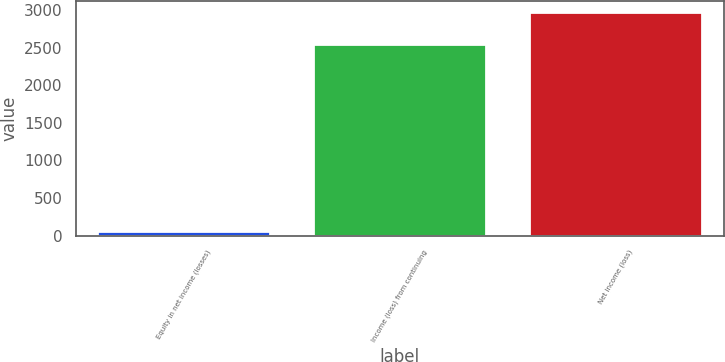Convert chart. <chart><loc_0><loc_0><loc_500><loc_500><bar_chart><fcel>Equity in net income (losses)<fcel>Income (loss) from continuing<fcel>Net income (loss)<nl><fcel>63<fcel>2549<fcel>2977.6<nl></chart> 